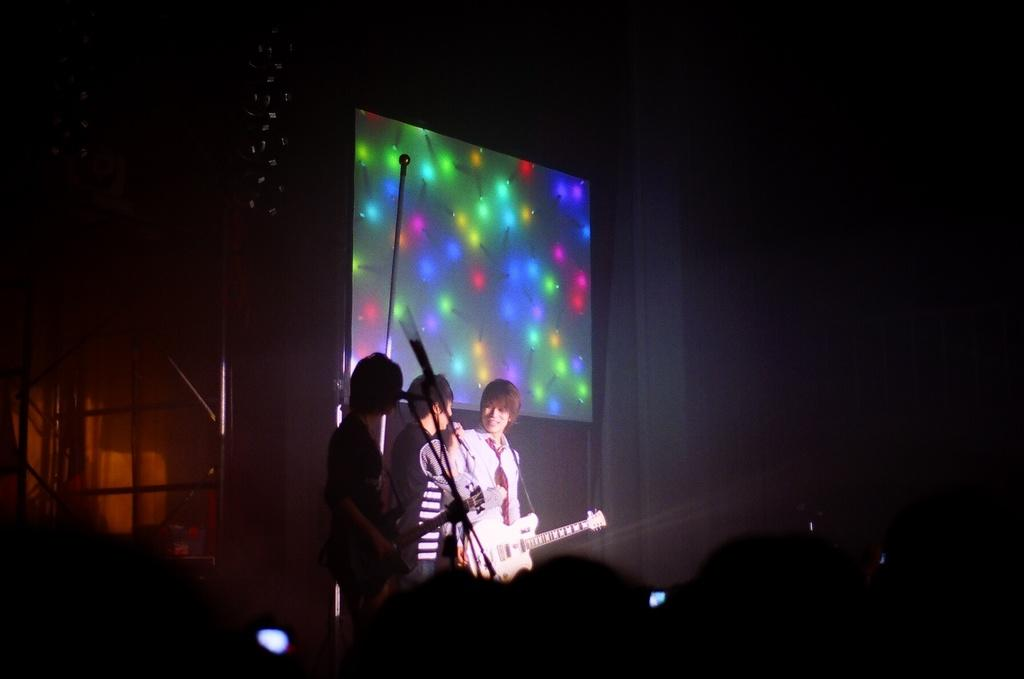How many people are on the stage in the image? There are three people on the stage in the image. What are the people doing on the stage? The people are performing on the stage. What are the people using to perform? The people are playing musical instruments. What can be seen behind the performers on the stage? There is a screen behind the performers on the stage. How many children are present on the stage, and what health advice are they giving? There is no mention of children in the image, and no health advice is being given. The image features three people playing musical instruments on a stage with a screen behind them. 